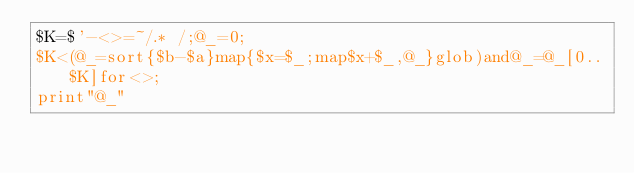Convert code to text. <code><loc_0><loc_0><loc_500><loc_500><_Perl_>$K=$'-<>=~/.* /;@_=0;
$K<(@_=sort{$b-$a}map{$x=$_;map$x+$_,@_}glob)and@_=@_[0..$K]for<>;
print"@_"</code> 